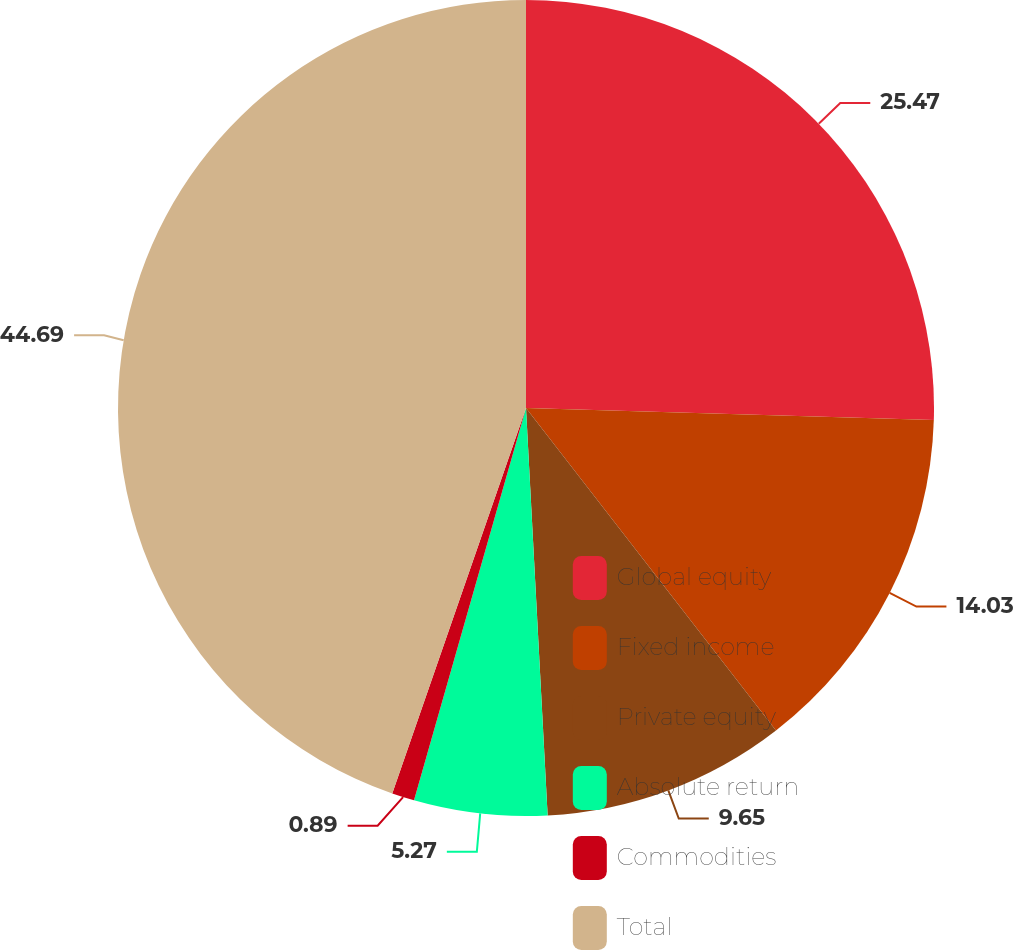Convert chart to OTSL. <chart><loc_0><loc_0><loc_500><loc_500><pie_chart><fcel>Global equity<fcel>Fixed income<fcel>Private equity<fcel>Absolute return<fcel>Commodities<fcel>Total<nl><fcel>25.47%<fcel>14.03%<fcel>9.65%<fcel>5.27%<fcel>0.89%<fcel>44.68%<nl></chart> 